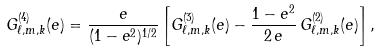<formula> <loc_0><loc_0><loc_500><loc_500>G ^ { ( 4 ) } _ { \ell , m , k } ( e ) = \frac { e } { ( 1 - e ^ { 2 } ) ^ { 1 / 2 } } \left [ G _ { \ell , m , k } ^ { ( 3 ) } ( e ) - \frac { 1 - e ^ { 2 } } { 2 \, e } \, G _ { \ell , m , k } ^ { ( 2 ) } ( e ) \right ] ,</formula> 